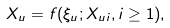<formula> <loc_0><loc_0><loc_500><loc_500>X _ { u } = f ( \xi _ { u } ; X _ { u i } , i \geq 1 ) ,</formula> 